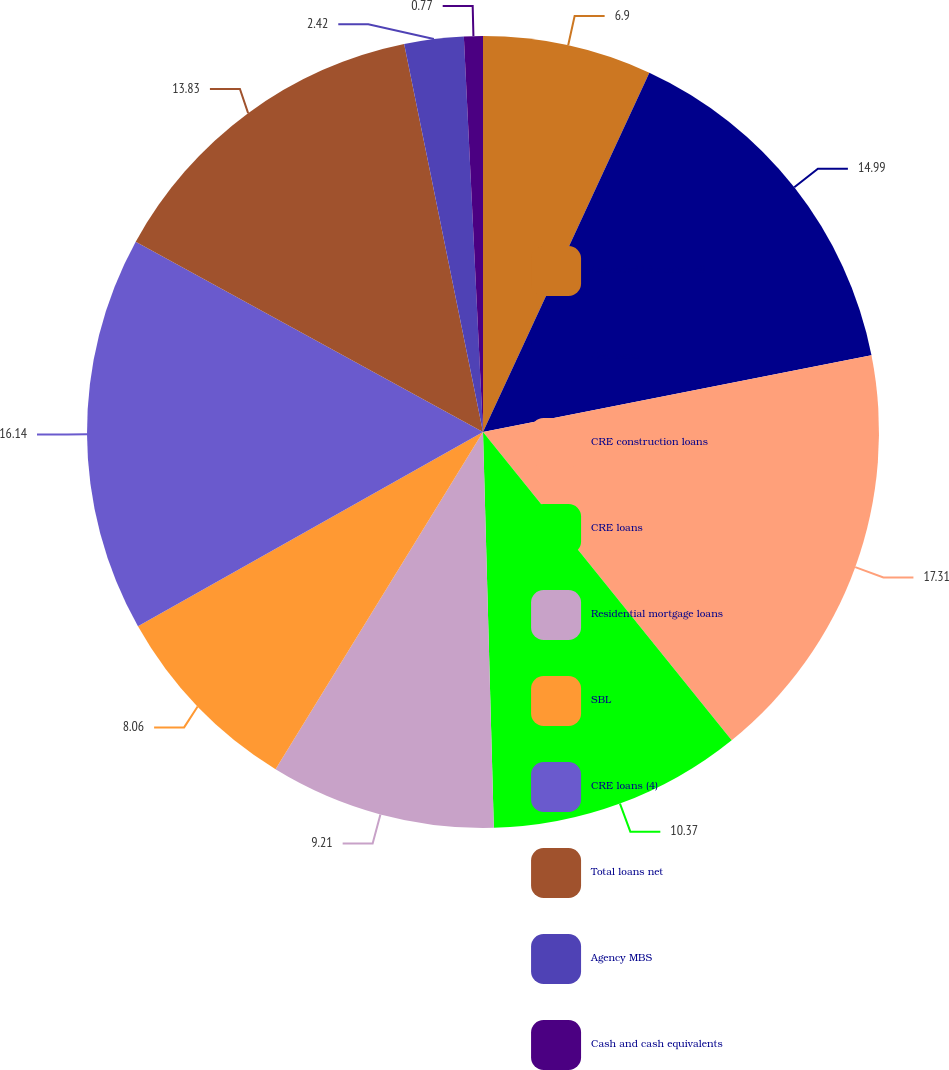<chart> <loc_0><loc_0><loc_500><loc_500><pie_chart><fcel>Loans held for sale - all<fcel>C&I loans<fcel>CRE construction loans<fcel>CRE loans<fcel>Residential mortgage loans<fcel>SBL<fcel>CRE loans (4)<fcel>Total loans net<fcel>Agency MBS<fcel>Cash and cash equivalents<nl><fcel>6.9%<fcel>14.99%<fcel>17.3%<fcel>10.37%<fcel>9.21%<fcel>8.06%<fcel>16.14%<fcel>13.83%<fcel>2.42%<fcel>0.77%<nl></chart> 